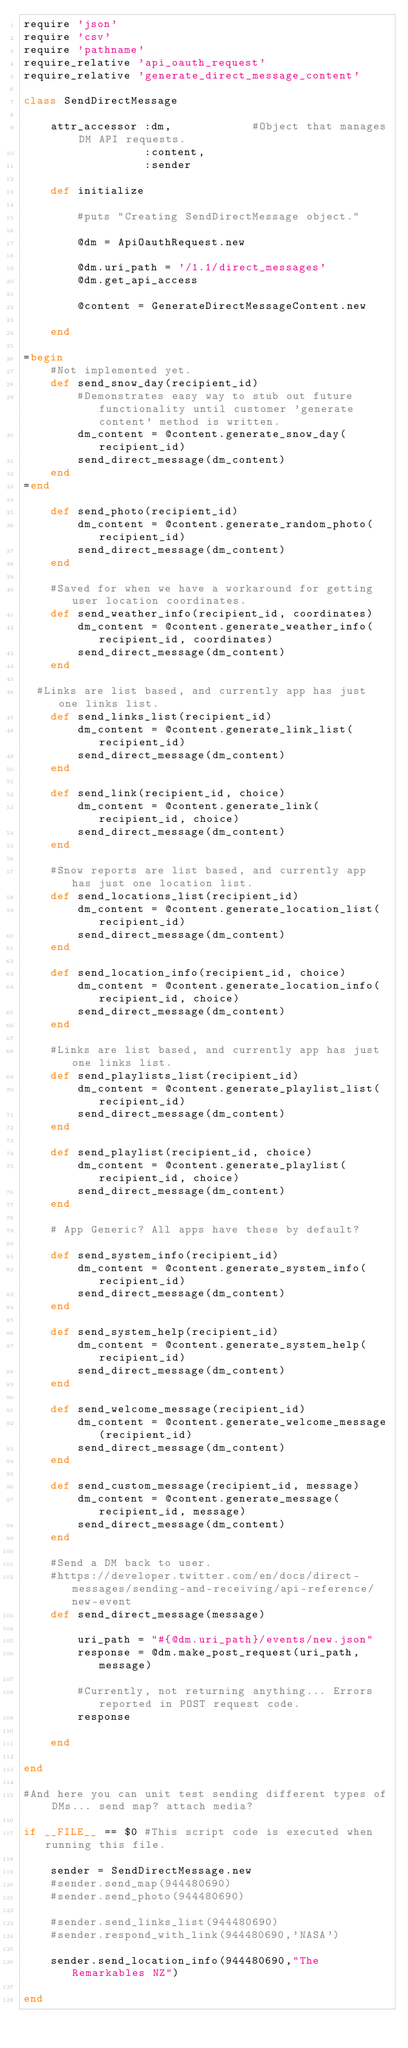<code> <loc_0><loc_0><loc_500><loc_500><_Ruby_>require 'json'
require 'csv'
require 'pathname'
require_relative 'api_oauth_request'
require_relative 'generate_direct_message_content'

class SendDirectMessage

	attr_accessor :dm,            #Object that manages DM API requests.
	              :content,
	              :sender

	def initialize

		#puts "Creating SendDirectMessage object."
		
		@dm = ApiOauthRequest.new

		@dm.uri_path = '/1.1/direct_messages'
		@dm.get_api_access

		@content = GenerateDirectMessageContent.new

	end

=begin
	#Not implemented yet.
	def send_snow_day(recipient_id)
		#Demonstrates easy way to stub out future functionality until customer 'generate content' method is written.
		dm_content = @content.generate_snow_day(recipient_id)
		send_direct_message(dm_content)
	end
=end

	def send_photo(recipient_id)
		dm_content = @content.generate_random_photo(recipient_id)
		send_direct_message(dm_content)
	end

	#Saved for when we have a workaround for getting user location coordinates.
	def send_weather_info(recipient_id, coordinates)
		dm_content = @content.generate_weather_info(recipient_id, coordinates)
		send_direct_message(dm_content)
	end
	
  #Links are list based, and currently app has just one links list. 
	def send_links_list(recipient_id)
		dm_content = @content.generate_link_list(recipient_id)
		send_direct_message(dm_content)
	end

	def send_link(recipient_id, choice)
		dm_content = @content.generate_link(recipient_id, choice)
		send_direct_message(dm_content)
	end

	#Snow reports are list based, and currently app has just one location list.
	def send_locations_list(recipient_id)
		dm_content = @content.generate_location_list(recipient_id)
		send_direct_message(dm_content)
	end

	def send_location_info(recipient_id, choice)
		dm_content = @content.generate_location_info(recipient_id, choice)
		send_direct_message(dm_content)
	end

	#Links are list based, and currently app has just one links list.
	def send_playlists_list(recipient_id)
		dm_content = @content.generate_playlist_list(recipient_id)
		send_direct_message(dm_content)
	end

	def send_playlist(recipient_id, choice)
		dm_content = @content.generate_playlist(recipient_id, choice)
		send_direct_message(dm_content)
	end
	
	# App Generic? All apps have these by default?

	def send_system_info(recipient_id)
		dm_content = @content.generate_system_info(recipient_id)
		send_direct_message(dm_content)
	end
	
	def send_system_help(recipient_id)
		dm_content = @content.generate_system_help(recipient_id)
		send_direct_message(dm_content)
	end

	def send_welcome_message(recipient_id)
		dm_content = @content.generate_welcome_message(recipient_id)
		send_direct_message(dm_content)
	end
	
	def send_custom_message(recipient_id, message)
		dm_content = @content.generate_message(recipient_id, message)
		send_direct_message(dm_content)
	end

	#Send a DM back to user.
	#https://developer.twitter.com/en/docs/direct-messages/sending-and-receiving/api-reference/new-event
	def send_direct_message(message)

		uri_path = "#{@dm.uri_path}/events/new.json"
		response = @dm.make_post_request(uri_path, message)
		
		#Currently, not returning anything... Errors reported in POST request code.
		response

	end

end

#And here you can unit test sending different types of DMs... send map? attach media?

if __FILE__ == $0 #This script code is executed when running this file.

	sender = SendDirectMessage.new
	#sender.send_map(944480690)
	#sender.send_photo(944480690)

	#sender.send_links_list(944480690)
	#sender.respond_with_link(944480690,'NASA')
	
	sender.send_location_info(944480690,"The Remarkables NZ")

end</code> 